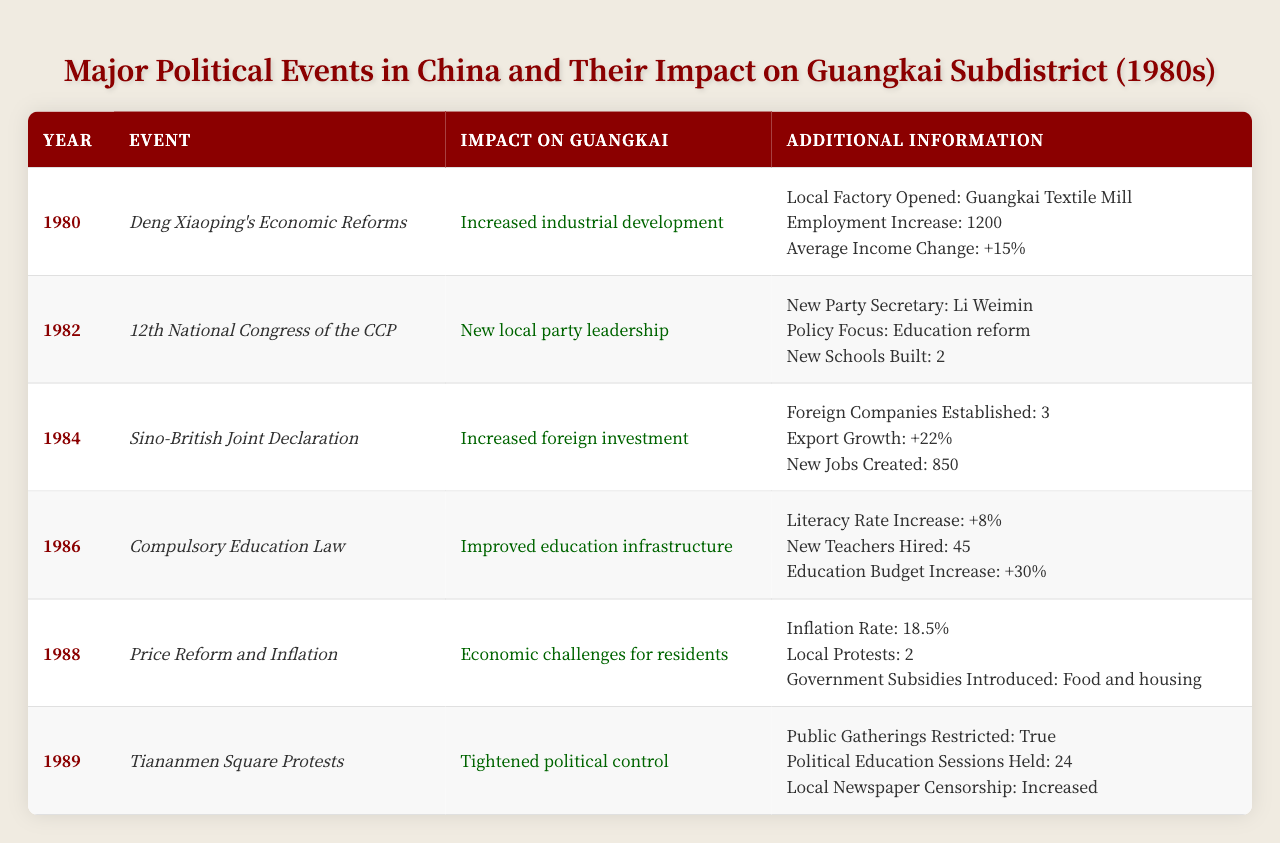What major event in 1980 led to increased industrial development in Guangkai? The table indicates that the major event in 1980 was Deng Xiaoping's Economic Reforms, which directly resulted in increased industrial development in Guangkai.
Answer: Deng Xiaoping's Economic Reforms How many new factories were established in Guangkai as a result of the events in 1984? In 1984, the table notes that 3 foreign companies were established, which can be interpreted as new factories being set up in Guangkai.
Answer: 3 What was the inflation rate in Guangkai during the price reform and inflation event of 1988? The table explicitly states that the inflation rate during the price reform and inflation event in 1988 was 18.5%.
Answer: 18.5% True or False: The literacy rate in Guangkai increased during the implementation of the Compulsory Education Law in 1986. The table shows that the literacy rate indeed increased by 8% following the enforcement of the Compulsory Education Law in 1986, confirming that the statement is true.
Answer: True What was the total increase in employment due to the major events listed in 1980 and 1984? The event in 1980 led to an increase in employment of 1200, and the event in 1984 added another 850 jobs, so the total increase in employment is 1200 + 850 = 2050.
Answer: 2050 Which event in 1989 resulted in tightened political control in Guangkai? The table mentions that the Tiananmen Square Protests in 1989 led to tightened political control in Guangkai, indicating the event's impact.
Answer: Tiananmen Square Protests What was the focus of the new local party leadership established in Guangkai after the 12th National Congress of the CCP in 1982? According to the table, the focus was on education reform, as indicated by the policies introduced by the new party secretary, Li Weimin.
Answer: Education reform How many local protests occurred in Guangkai in 1988 as a result of economic challenges? The table specifies that there were 2 local protests in Guangkai due to the economic challenges faced during the price reform and inflation in 1988.
Answer: 2 What was the average increase in income in Guangkai following Deng Xiaoping's economic reforms in 1980? The table states that there was an average income increase of 15% as a result of Deng Xiaoping's Economic Reforms in 1980.
Answer: +15% List the number of new schools built in Guangkai due to the policies from the 12th National Congress of the CCP in 1982. The table indicates that 2 new schools were built in Guangkai as a direct result of the policy focus on education reform from the new local party leadership.
Answer: 2 What are the additional measures introduced to support residents during the economic challenges of 1988? As stated in the table, the government introduced subsidies for food and housing to support residents during the inflation and economic challenges of 1988.
Answer: Food and housing subsidies 